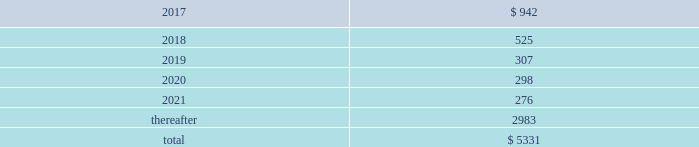We , in the normal course of business operations , have issued product warranties related to equipment sales .
Also , contracts often contain standard terms and conditions which typically include a warranty and indemnification to the buyer that the goods and services purchased do not infringe on third-party intellectual property rights .
The provision for estimated future costs relating to warranties is not material to the consolidated financial statements .
We do not expect that any sum we may have to pay in connection with guarantees and warranties will have a material adverse effect on our consolidated financial condition , liquidity , or results of operations .
Unconditional purchase obligations we are obligated to make future payments under unconditional purchase obligations as summarized below: .
Approximately $ 4000 of our unconditional purchase obligations relate to helium purchases , which include crude feedstock supply to multiple helium refining plants in north america as well as refined helium purchases from sources around the world .
As a rare byproduct of natural gas production in the energy sector , these helium sourcing agreements are medium- to long-term and contain take-or-pay provisions .
The refined helium is distributed globally and sold as a merchant gas , primarily under medium-term requirements contracts .
While contract terms in the energy sector are longer than those in merchant , helium is a rare gas used in applications with few or no substitutions because of its unique physical and chemical properties .
Approximately $ 330 of our long-term unconditional purchase obligations relate to feedstock supply for numerous hyco ( hydrogen , carbon monoxide , and syngas ) facilities .
The price of feedstock supply is principally related to the price of natural gas .
However , long-term take-or-pay sales contracts to hyco customers are generally matched to the term of the feedstock supply obligations and provide recovery of price increases in the feedstock supply .
Due to the matching of most long-term feedstock supply obligations to customer sales contracts , we do not believe these purchase obligations would have a material effect on our financial condition or results of operations .
The unconditional purchase obligations also include other product supply and purchase commitments and electric power and natural gas supply purchase obligations , which are primarily pass-through contracts with our customers .
Purchase commitments to spend approximately $ 350 for additional plant and equipment are included in the unconditional purchase obligations in 2017 .
In addition , we have purchase commitments totaling approximately $ 500 in 2017 and 2018 relating to our long-term sale of equipment project for saudi aramco 2019s jazan oil refinery .
18 .
Capital stock common stock authorized common stock consists of 300 million shares with a par value of $ 1 per share .
As of 30 september 2016 , 249 million shares were issued , with 217 million outstanding .
On 15 september 2011 , the board of directors authorized the repurchase of up to $ 1000 of our outstanding common stock .
We repurchase shares pursuant to rules 10b5-1 and 10b-18 under the securities exchange act of 1934 , as amended , through repurchase agreements established with several brokers .
We did not purchase any of our outstanding shares during fiscal year 2016 .
At 30 september 2016 , $ 485.3 in share repurchase authorization remains. .
Considering the total unconditional purchase obligations , what is the percentage of helium purchases concerning the total value? 
Rationale: it is the value of helium purchases divided by the total unconditional purchase obligations , then turned into a percentage .
Computations: (4000 / 5331)
Answer: 0.75033. 